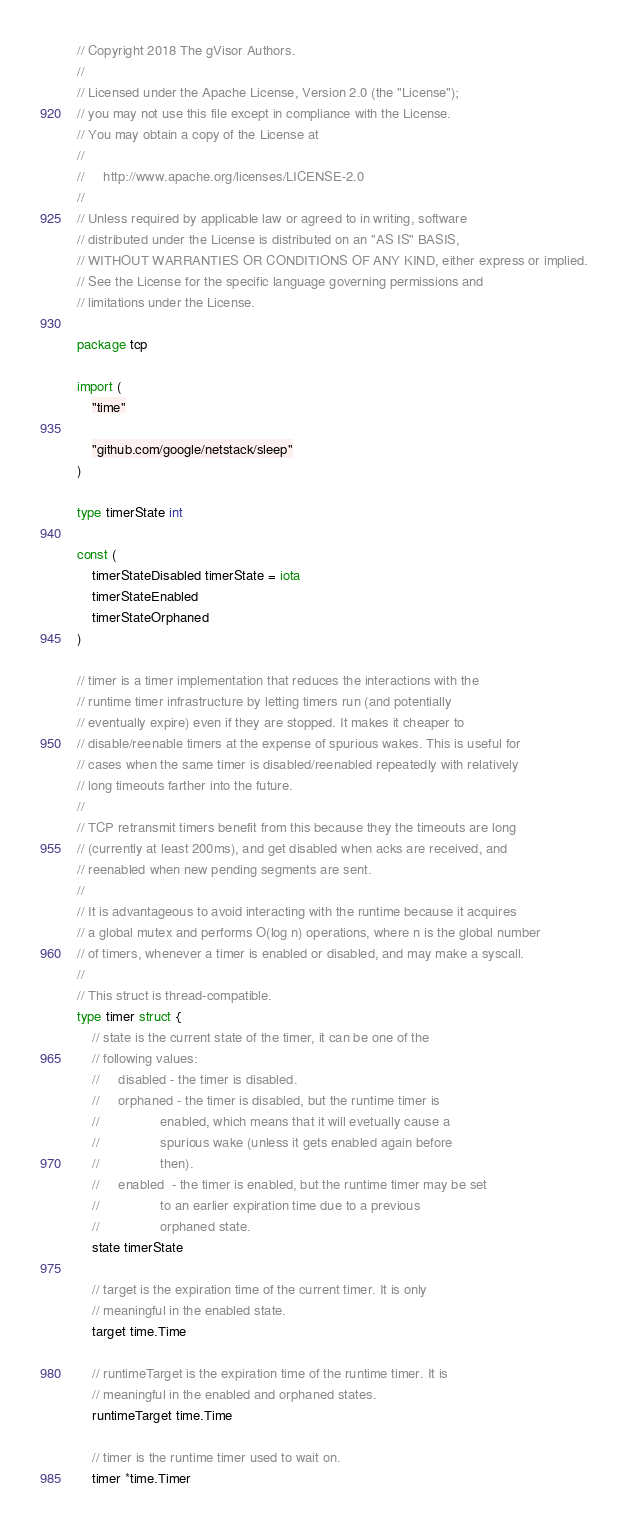<code> <loc_0><loc_0><loc_500><loc_500><_Go_>// Copyright 2018 The gVisor Authors.
//
// Licensed under the Apache License, Version 2.0 (the "License");
// you may not use this file except in compliance with the License.
// You may obtain a copy of the License at
//
//     http://www.apache.org/licenses/LICENSE-2.0
//
// Unless required by applicable law or agreed to in writing, software
// distributed under the License is distributed on an "AS IS" BASIS,
// WITHOUT WARRANTIES OR CONDITIONS OF ANY KIND, either express or implied.
// See the License for the specific language governing permissions and
// limitations under the License.

package tcp

import (
	"time"

	"github.com/google/netstack/sleep"
)

type timerState int

const (
	timerStateDisabled timerState = iota
	timerStateEnabled
	timerStateOrphaned
)

// timer is a timer implementation that reduces the interactions with the
// runtime timer infrastructure by letting timers run (and potentially
// eventually expire) even if they are stopped. It makes it cheaper to
// disable/reenable timers at the expense of spurious wakes. This is useful for
// cases when the same timer is disabled/reenabled repeatedly with relatively
// long timeouts farther into the future.
//
// TCP retransmit timers benefit from this because they the timeouts are long
// (currently at least 200ms), and get disabled when acks are received, and
// reenabled when new pending segments are sent.
//
// It is advantageous to avoid interacting with the runtime because it acquires
// a global mutex and performs O(log n) operations, where n is the global number
// of timers, whenever a timer is enabled or disabled, and may make a syscall.
//
// This struct is thread-compatible.
type timer struct {
	// state is the current state of the timer, it can be one of the
	// following values:
	//     disabled - the timer is disabled.
	//     orphaned - the timer is disabled, but the runtime timer is
	//                enabled, which means that it will evetually cause a
	//                spurious wake (unless it gets enabled again before
	//                then).
	//     enabled  - the timer is enabled, but the runtime timer may be set
	//                to an earlier expiration time due to a previous
	//                orphaned state.
	state timerState

	// target is the expiration time of the current timer. It is only
	// meaningful in the enabled state.
	target time.Time

	// runtimeTarget is the expiration time of the runtime timer. It is
	// meaningful in the enabled and orphaned states.
	runtimeTarget time.Time

	// timer is the runtime timer used to wait on.
	timer *time.Timer</code> 